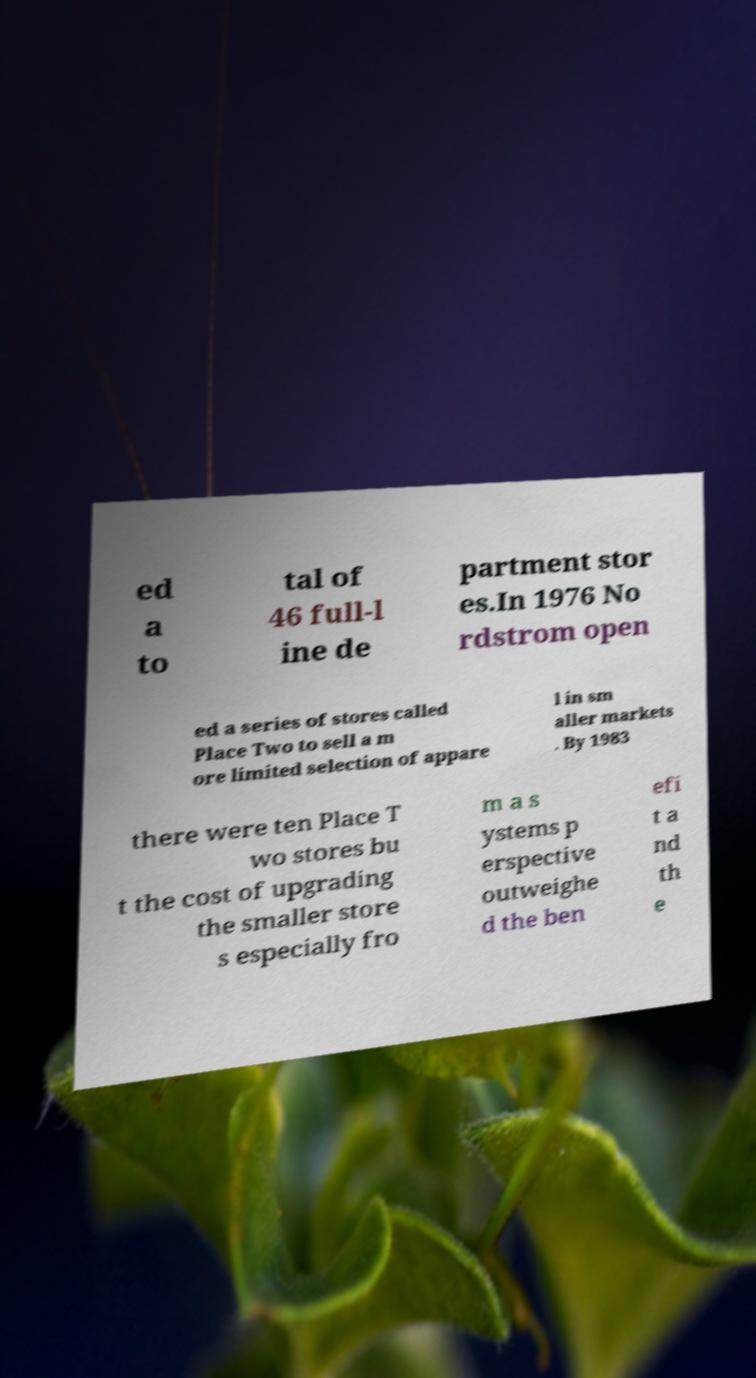Please read and relay the text visible in this image. What does it say? ed a to tal of 46 full-l ine de partment stor es.In 1976 No rdstrom open ed a series of stores called Place Two to sell a m ore limited selection of appare l in sm aller markets . By 1983 there were ten Place T wo stores bu t the cost of upgrading the smaller store s especially fro m a s ystems p erspective outweighe d the ben efi t a nd th e 